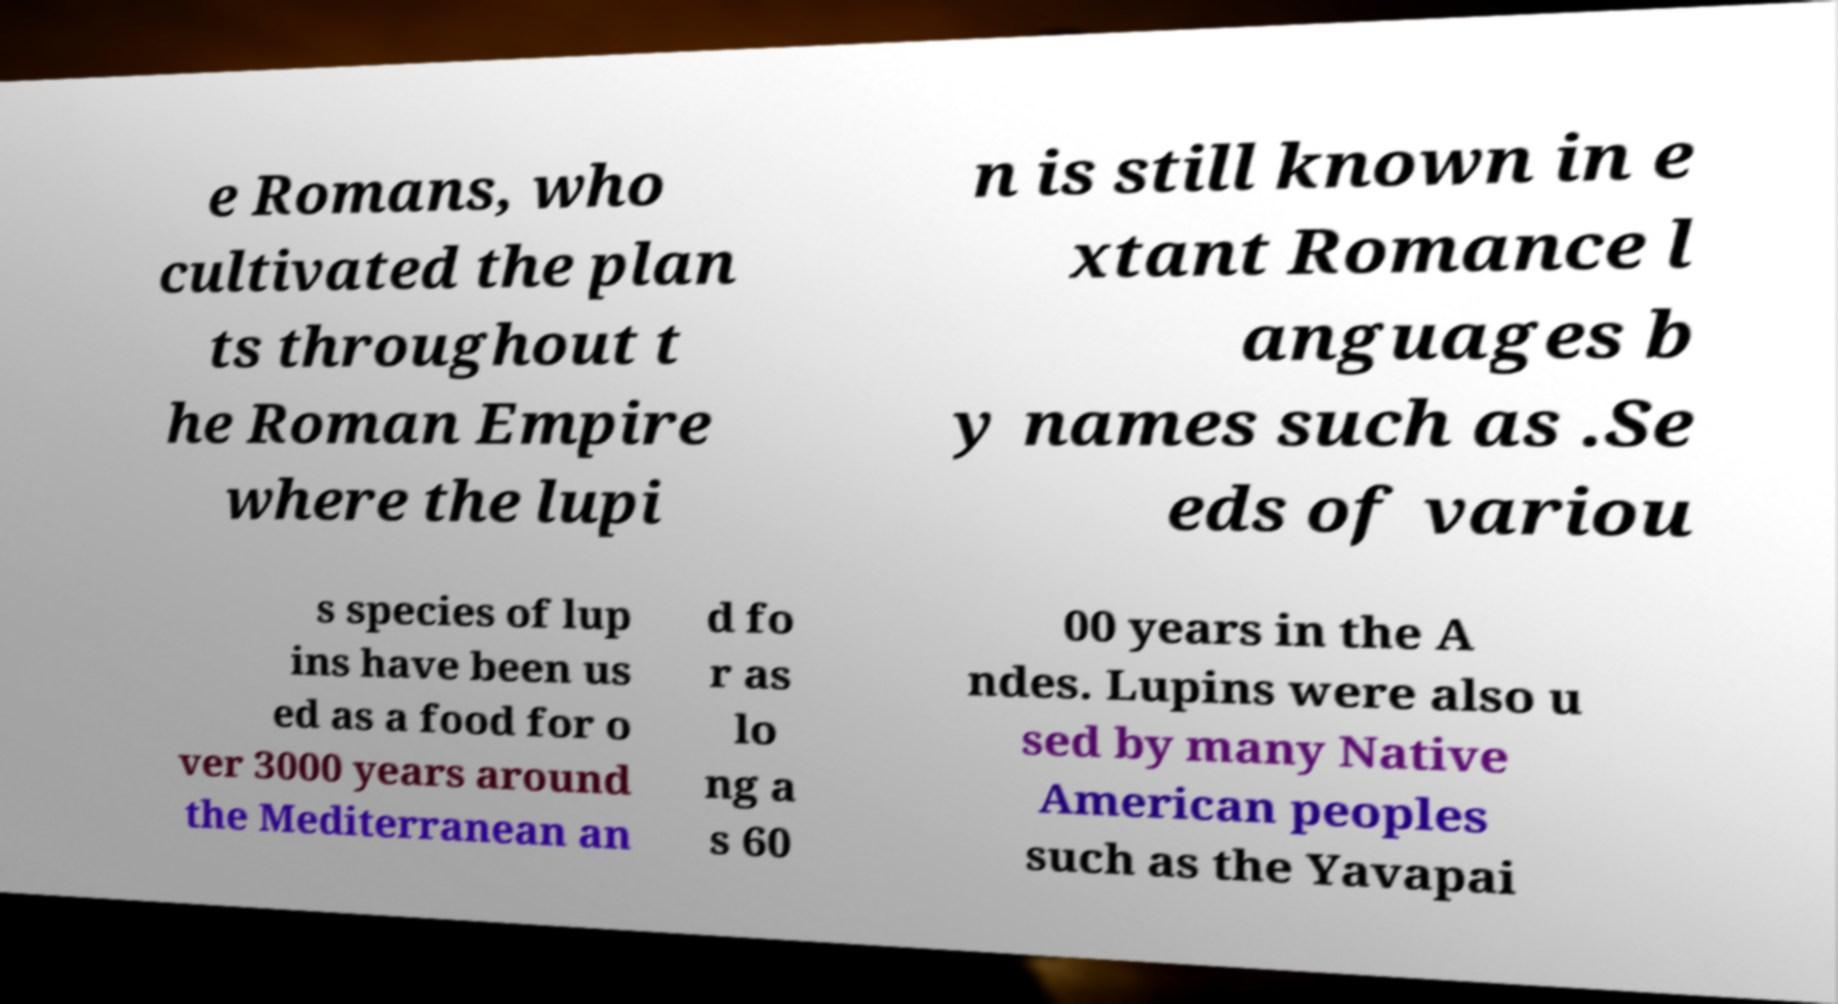What messages or text are displayed in this image? I need them in a readable, typed format. e Romans, who cultivated the plan ts throughout t he Roman Empire where the lupi n is still known in e xtant Romance l anguages b y names such as .Se eds of variou s species of lup ins have been us ed as a food for o ver 3000 years around the Mediterranean an d fo r as lo ng a s 60 00 years in the A ndes. Lupins were also u sed by many Native American peoples such as the Yavapai 